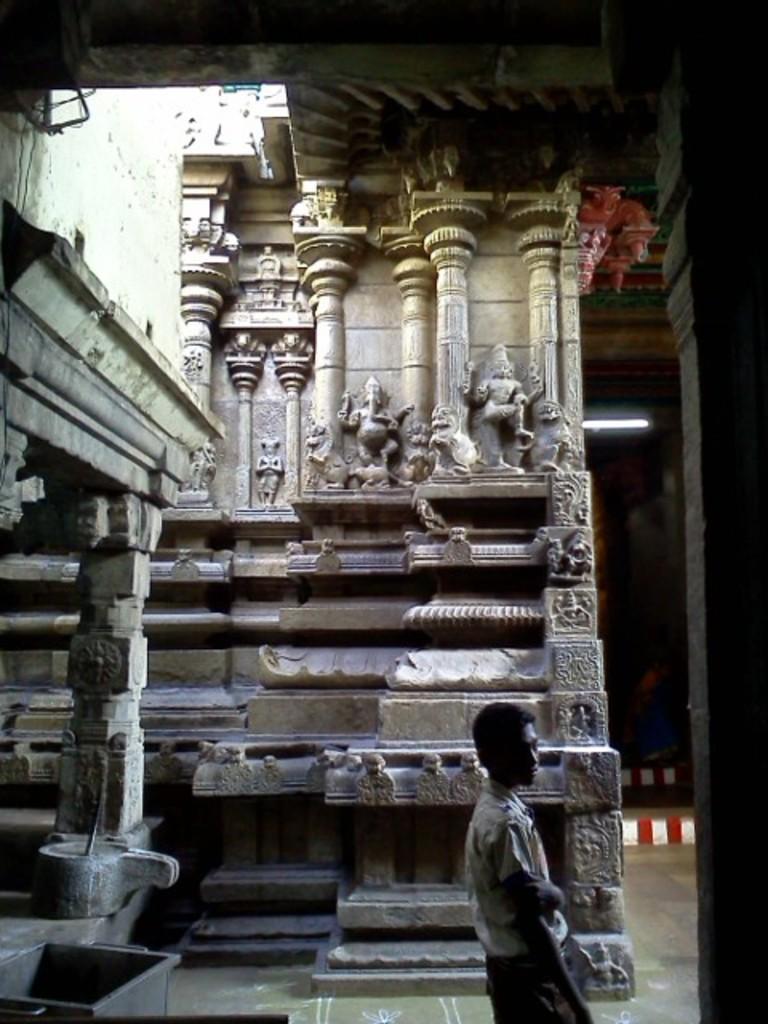In one or two sentences, can you explain what this image depicts? In this picture I can see stone carving on the pillars and walls, looks like a temple and I can see a man standing and a metal box on the left side, 